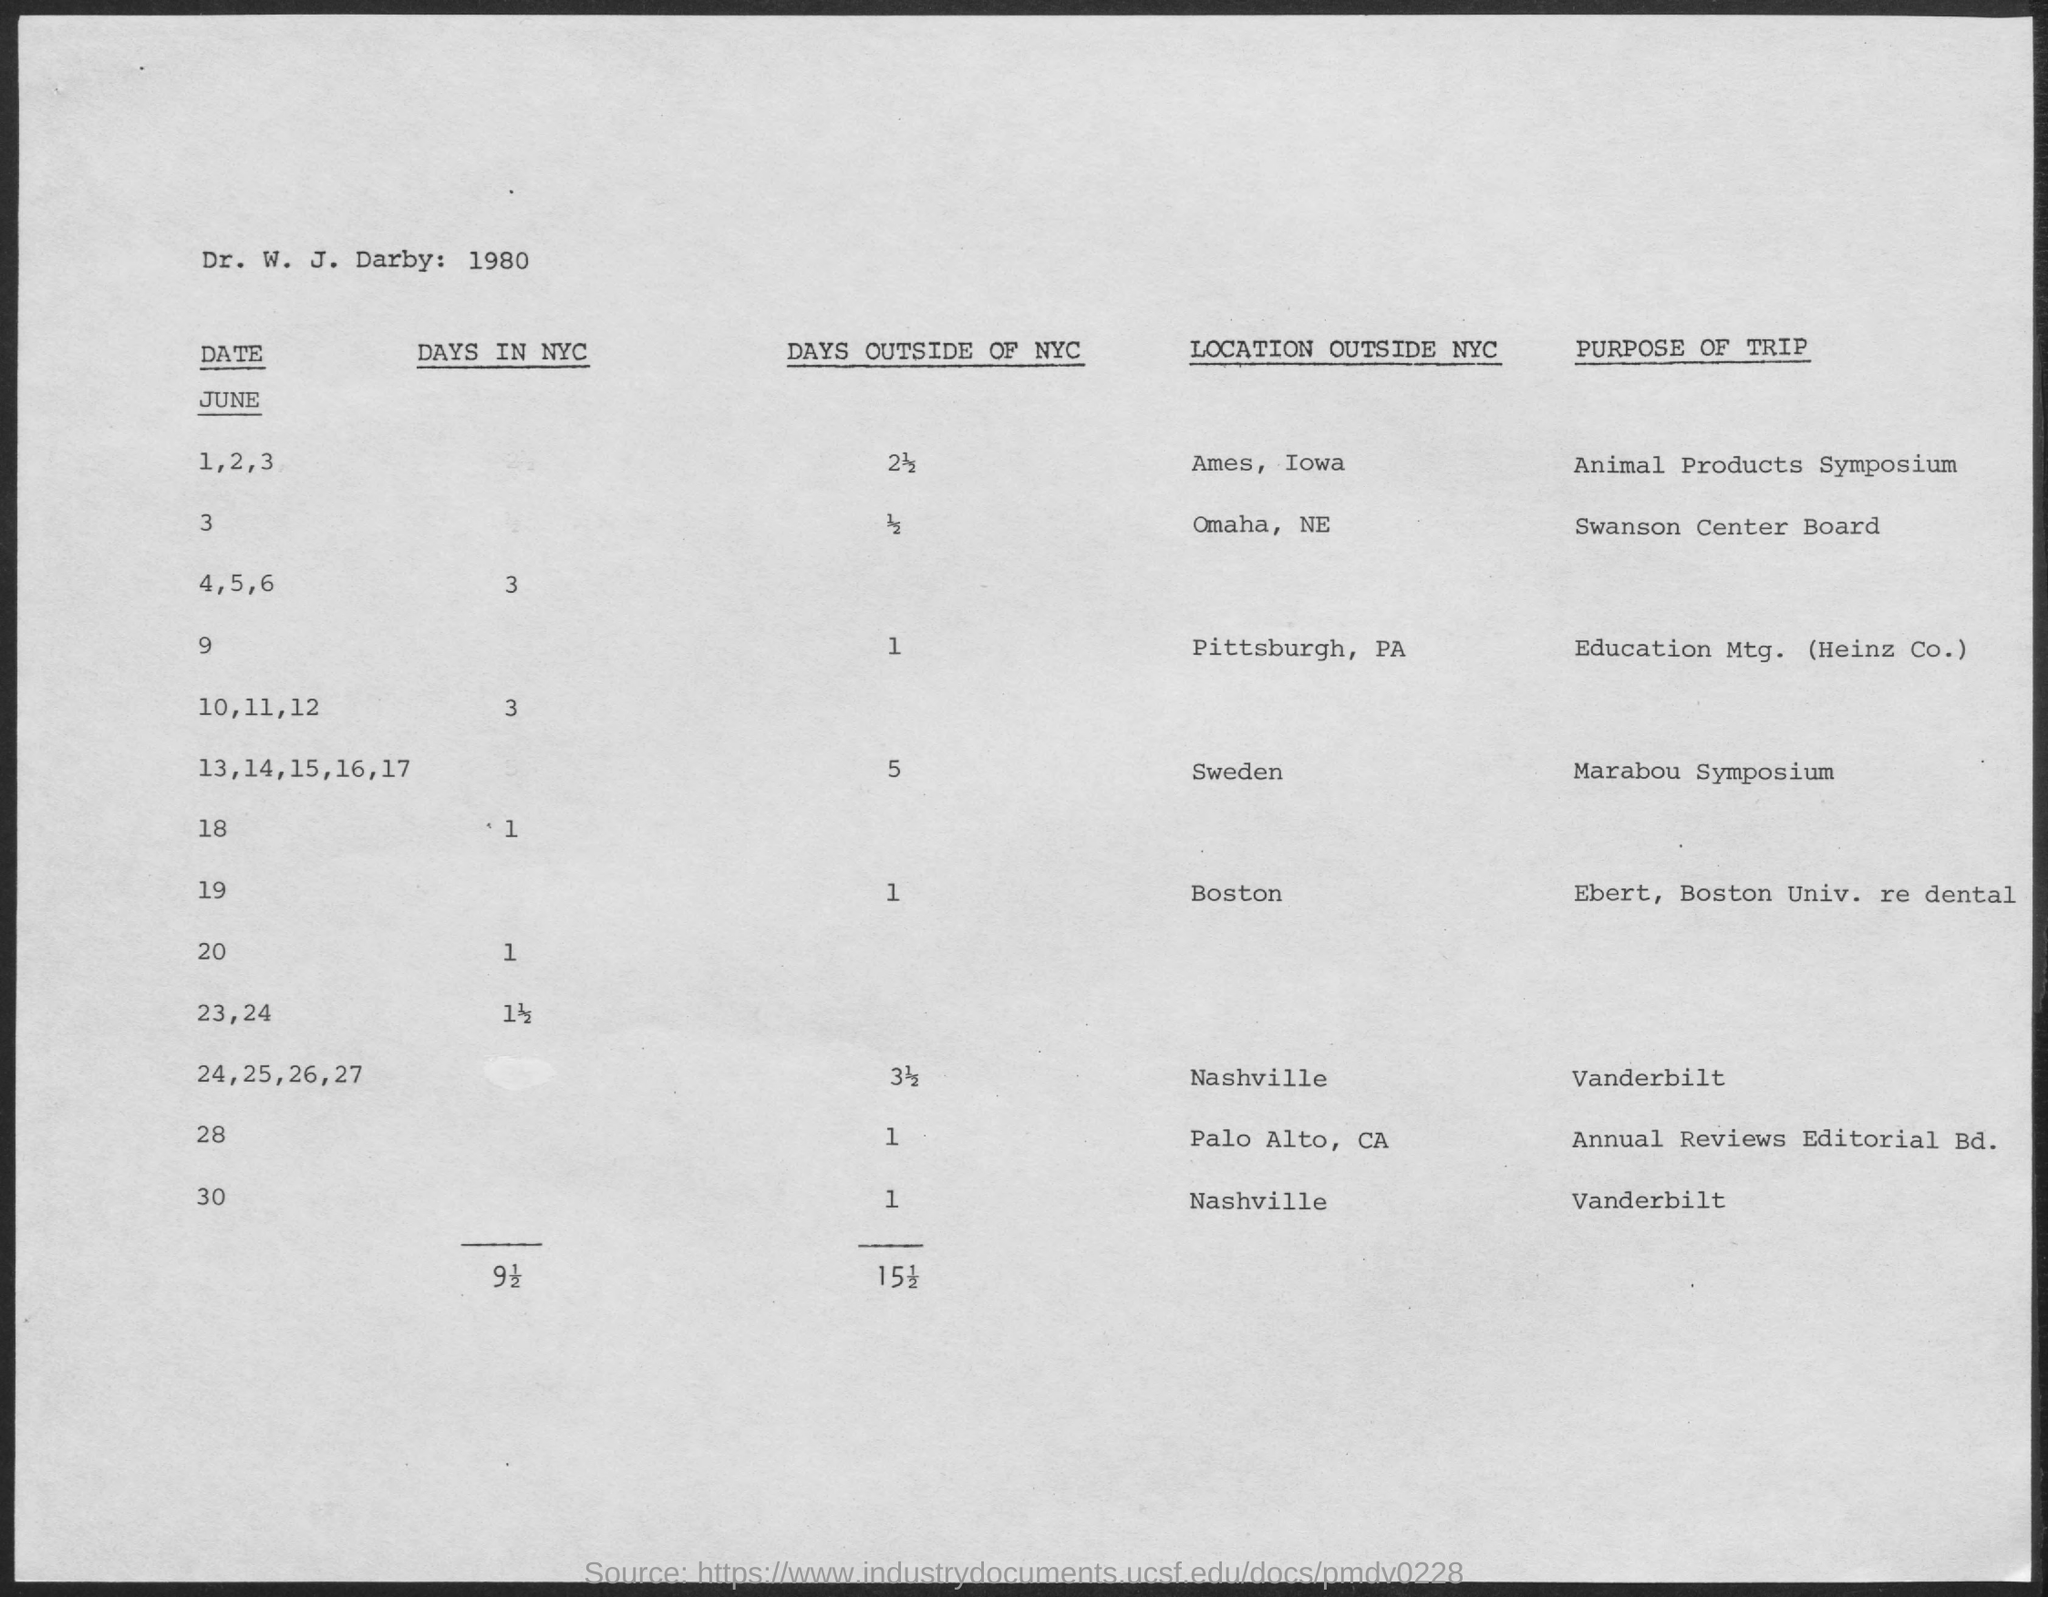Specify some key components in this picture. I, [your name], hereby declare that on June 1, 2, and 3, I will be embarking on a trip with the purpose of attending the Animal Products Symposium. The Marabou Symposium will be held in Sweden. 